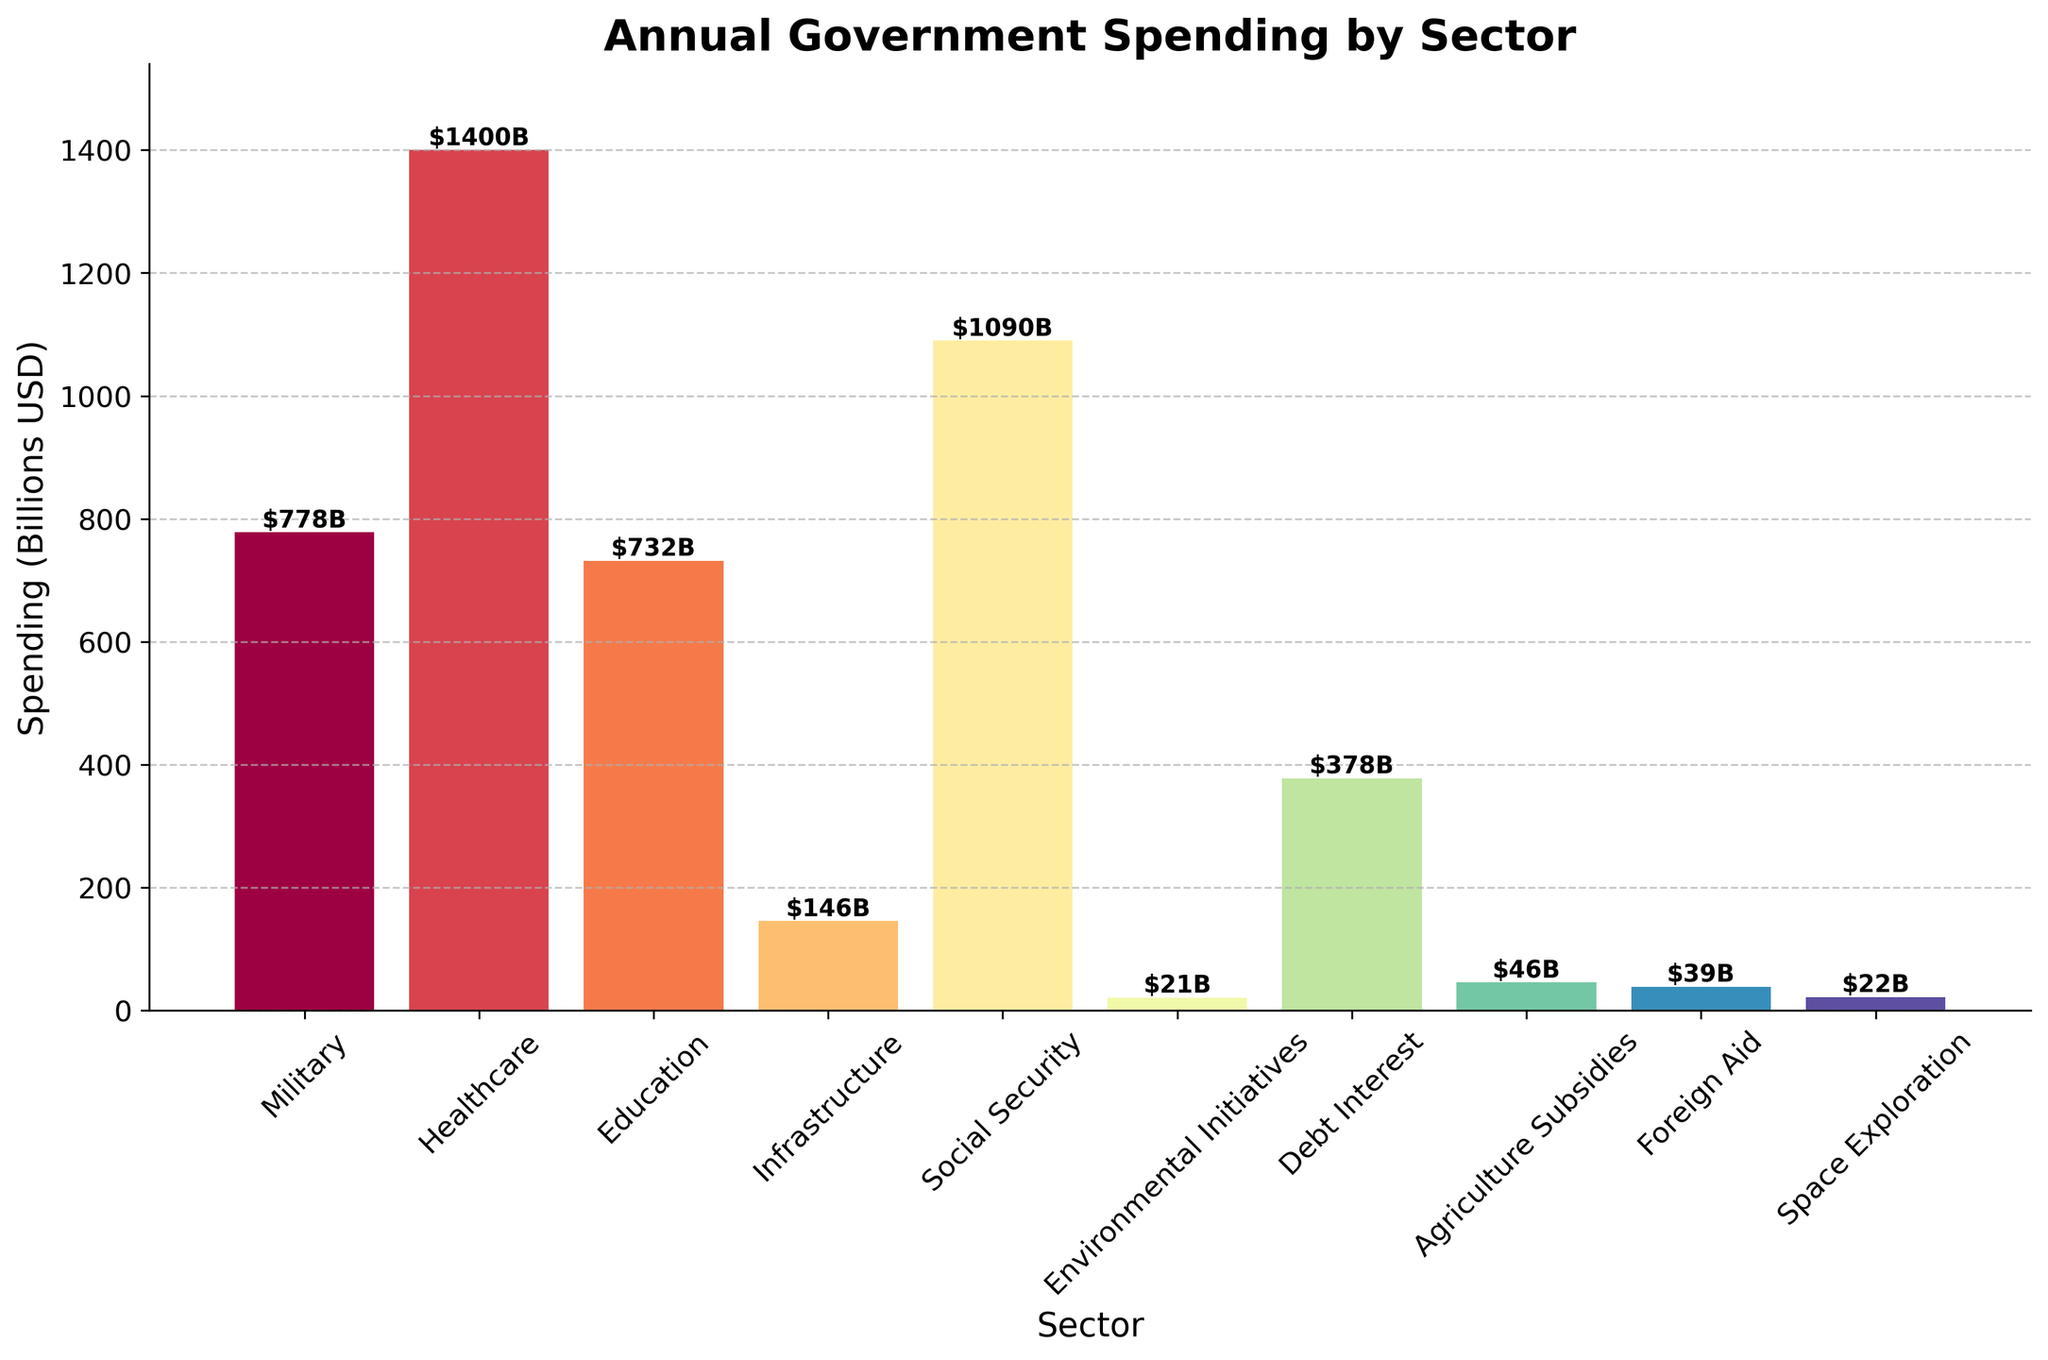what is the total spending on military, healthcare, and education combined? To find the total spending on military, healthcare, and education combined, we sum up the individual spendings: Military ($778B) + Healthcare ($1400B) + Education ($732B) = $2910B.
Answer: $2910B how much more is spent on social security compared to environmental initiatives? To determine the difference, we subtract the spending on environmental initiatives from the spending on social security: Social Security ($1090B) - Environmental Initiatives ($21B) = $1069B.
Answer: $1069B which sector receives the least funding? By comparing the heights of the bars, it is clear that the bar representing Environmental Initiatives is the shortest, indicating it receives the least funding.
Answer: Environmental Initiatives how does the spending on infrastructure compare to the spending on foreign aid? We compare the spending values: Infrastructure ($146B) is greater than Foreign Aid ($39B).
Answer: Infrastructure has more spending what is the average spending across all sectors? Sum the spending across all sectors and divide by the number of sectors: (778 + 1400 + 732 + 146 + 1090 + 21 + 378 + 46 + 39 + 22) / 10 = 4652 / 10 = $465.2B.
Answer: $465.2B how is the spending on debt interest visually represented compared to space exploration? The bar for Debt Interest ($378B) is significantly taller than the bar for Space Exploration ($22B), indicating much higher spending on Debt Interest.
Answer: Debt Interest is visually much taller if the spending on environmental initiatives were doubled, how would it compare to agriculture subsidies? Doubling the spending on Environmental Initiatives: 21 * 2 = $42B. Agriculture Subsidies are $46B, so Agriculture Subsidies would still receive more funding than the doubled Environmental Initiatives.
Answer: Agriculture Subsidies would still be higher what is the range of spending among all sectors? The range is calculated by subtracting the smallest spending from the largest: $1400B (Healthcare) - $21B (Environmental Initiatives) = $1379B.
Answer: $1379B if the government cuts 20% of its spending on healthcare, what would be the new amount? Reducing Healthcare spending by 20%: 1400 - (1400 * 0.2) = 1400 - 280 = $1120B.
Answer: $1120B 